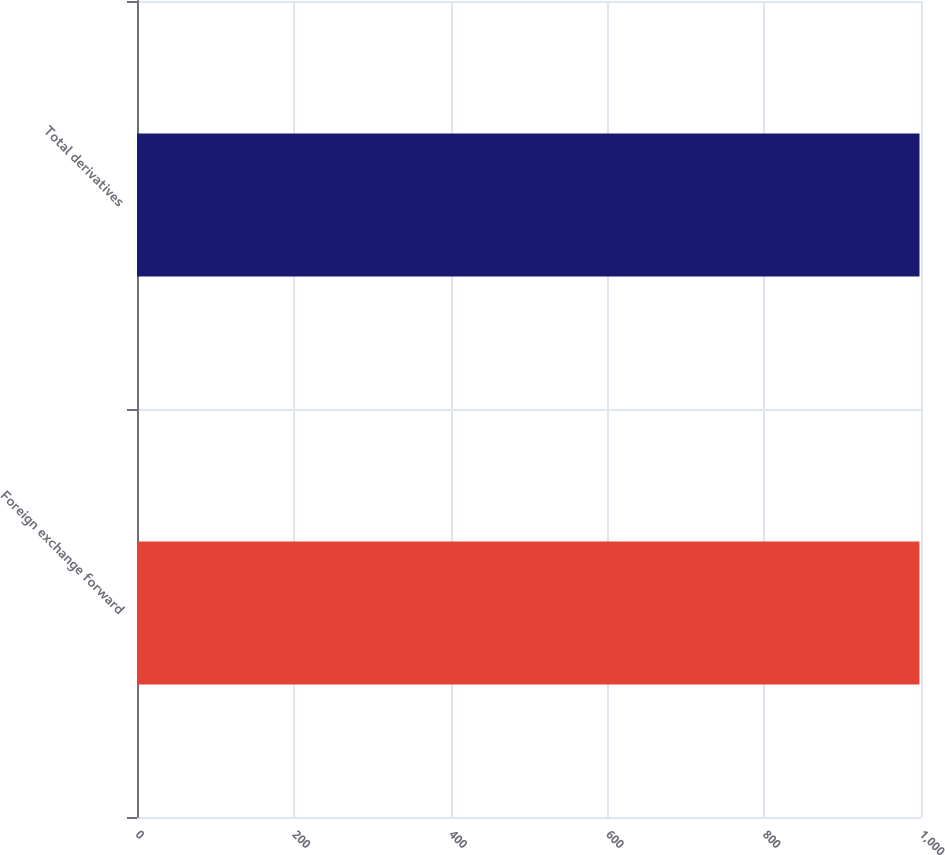<chart> <loc_0><loc_0><loc_500><loc_500><bar_chart><fcel>Foreign exchange forward<fcel>Total derivatives<nl><fcel>998<fcel>998.1<nl></chart> 